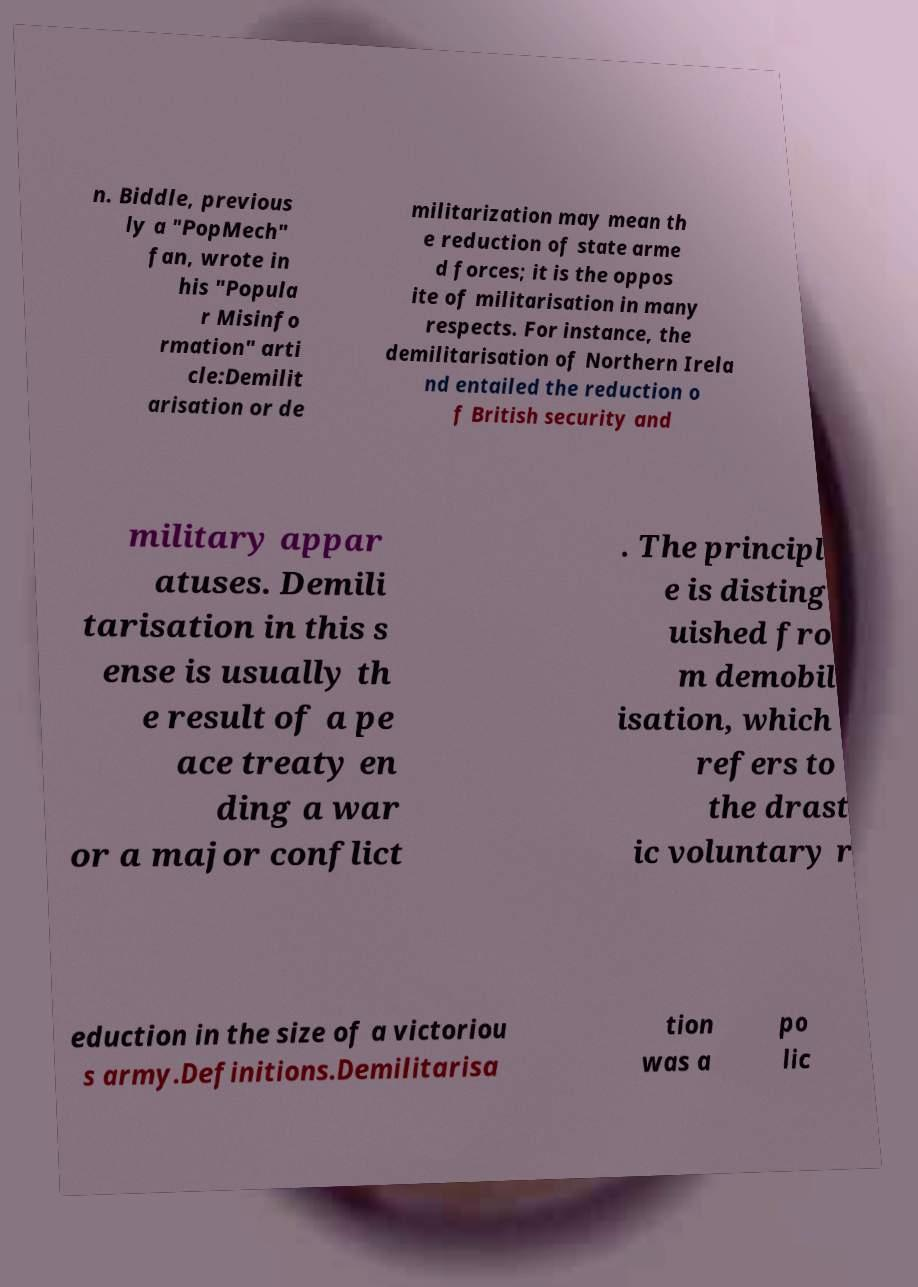Please identify and transcribe the text found in this image. n. Biddle, previous ly a "PopMech" fan, wrote in his "Popula r Misinfo rmation" arti cle:Demilit arisation or de militarization may mean th e reduction of state arme d forces; it is the oppos ite of militarisation in many respects. For instance, the demilitarisation of Northern Irela nd entailed the reduction o f British security and military appar atuses. Demili tarisation in this s ense is usually th e result of a pe ace treaty en ding a war or a major conflict . The principl e is disting uished fro m demobil isation, which refers to the drast ic voluntary r eduction in the size of a victoriou s army.Definitions.Demilitarisa tion was a po lic 